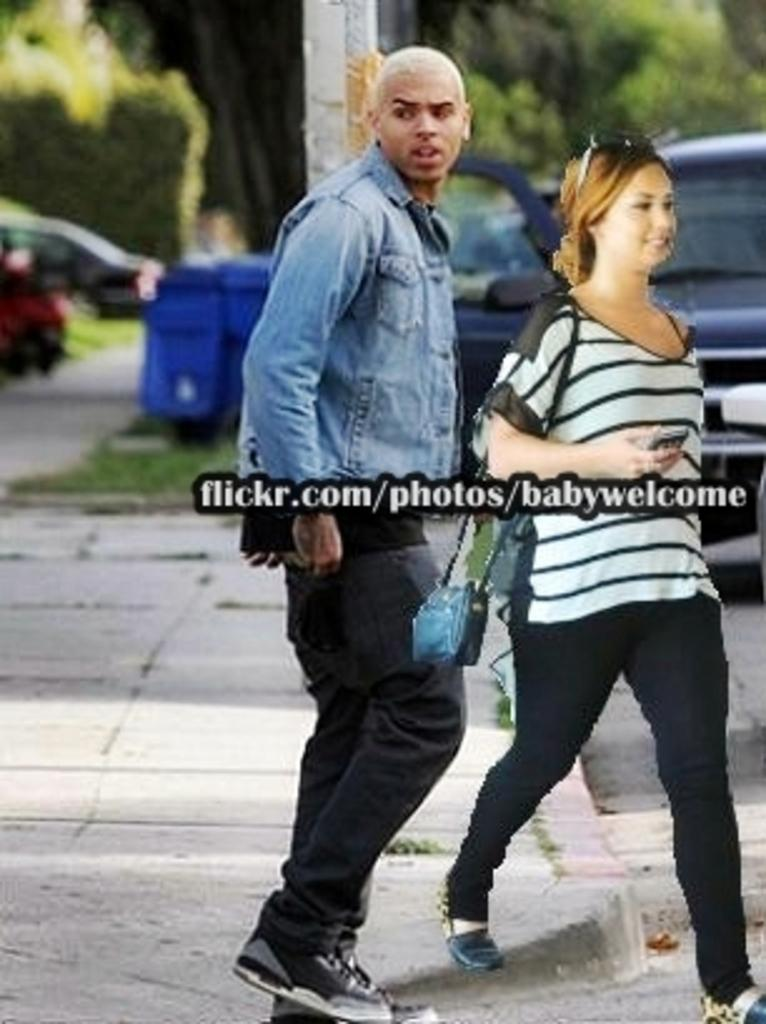Provide a one-sentence caption for the provided image. A man and a woman are walking down the sidewalk while the man looks to his right. 